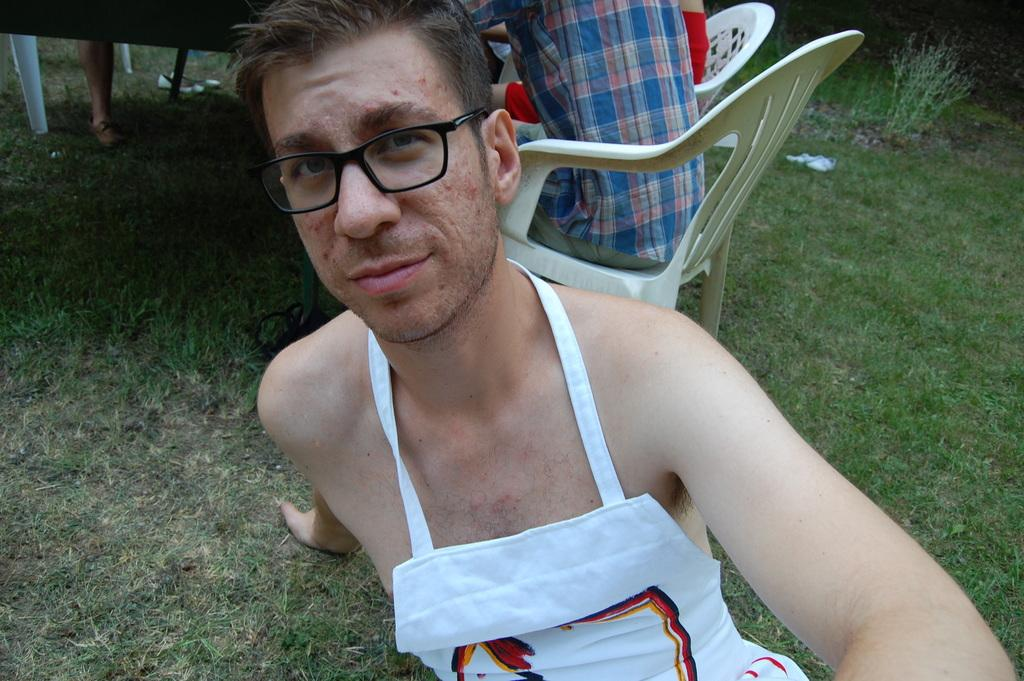What is the man in the image doing? The man is sitting on the ground in the image. Can you describe the man's appearance? The man is wearing spectacles. What is happening behind the man in the image? There are people sitting on chairs behind the man. What type of vegetation is present on the ground? There are plants and grass on the ground. How does the man's breath affect the trail in the image? There is no trail present in the image, and the man's breath is not visible. 